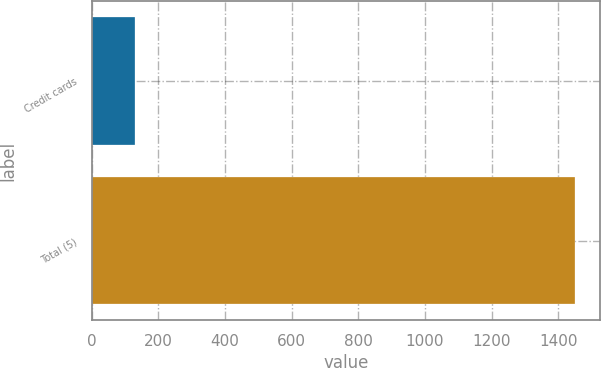Convert chart. <chart><loc_0><loc_0><loc_500><loc_500><bar_chart><fcel>Credit cards<fcel>Total (5)<nl><fcel>131<fcel>1452<nl></chart> 